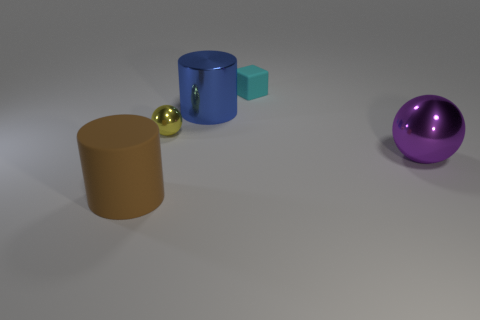How do the shadows in the image contribute to the perception of the objects' sizes? The shadows cast by each object in the image enhance the three-dimensional perception of their forms. The elongated shadows suggest a directional light source to the left, making objects appear more grounded and providing a sense of scale and depth, emphasizing the relative sizes and distances between the objects. 